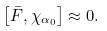Convert formula to latex. <formula><loc_0><loc_0><loc_500><loc_500>\left [ \bar { F } , \chi _ { \alpha _ { 0 } } \right ] \approx 0 .</formula> 